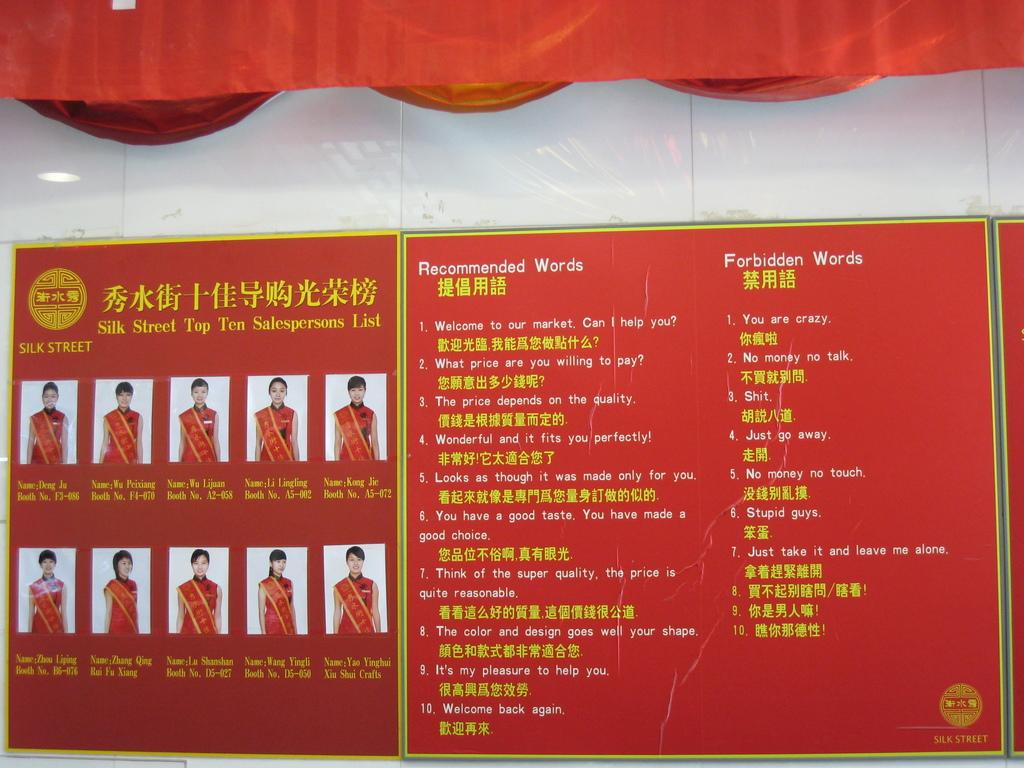<image>
Share a concise interpretation of the image provided. A red poster displays two lists, one of recommended words and one of forbidden words. 